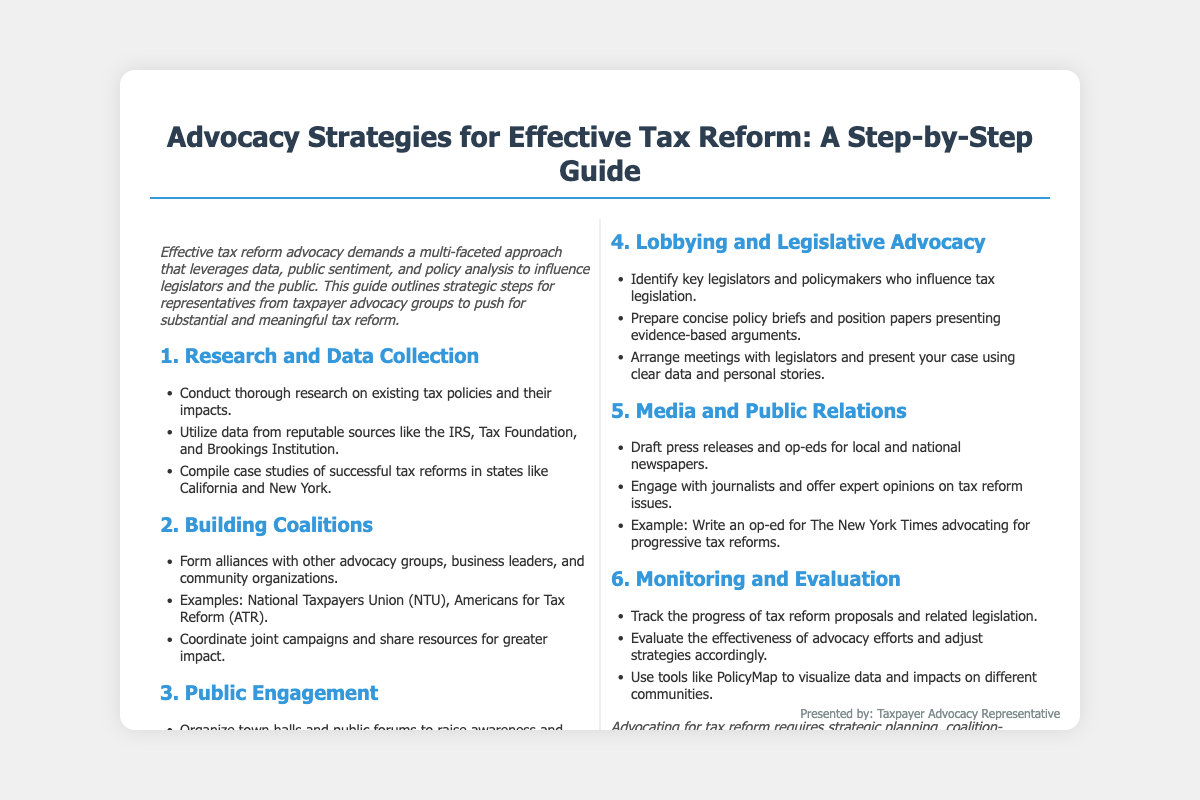What is the title of the presentation? The title of the presentation is clearly indicated at the top of the document as the main heading.
Answer: Advocacy Strategies for Effective Tax Reform: A Step-by-Step Guide What is the first step in the advocacy strategies? The presentation outlines various steps for advocacy, with the first being the initial strategy listed.
Answer: Research and Data Collection Which organization is mentioned as an example of coalition-building? The document provides specific examples of organizations that can form coalitions within the advocacy strategy.
Answer: National Taxpayers Union (NTU) How many steps are outlined in the advocacy strategies? The total number of distinct steps is summarized in the document and can be easily counted based on headings.
Answer: Six What is the aim of public engagement strategies? The presentation highlights the purpose and expected outcomes of public engagement, summarizing its importance.
Answer: Raise awareness and gather feedback Which social media platforms are suggested for outreach? The document lists specific platforms ideal for engaging with the public, providing targeted suggestions.
Answer: Twitter, Facebook, and LinkedIn What should be tracked according to the monitoring and evaluation step? The document specifies what aspect of the tax reform proposals requires ongoing attention in the evaluation process.
Answer: Progress of tax reform proposals What type of content should be drafted for media relations? The presentation discusses specific content types that are recommended for creating media engagement and outreach.
Answer: Press releases and op-eds 